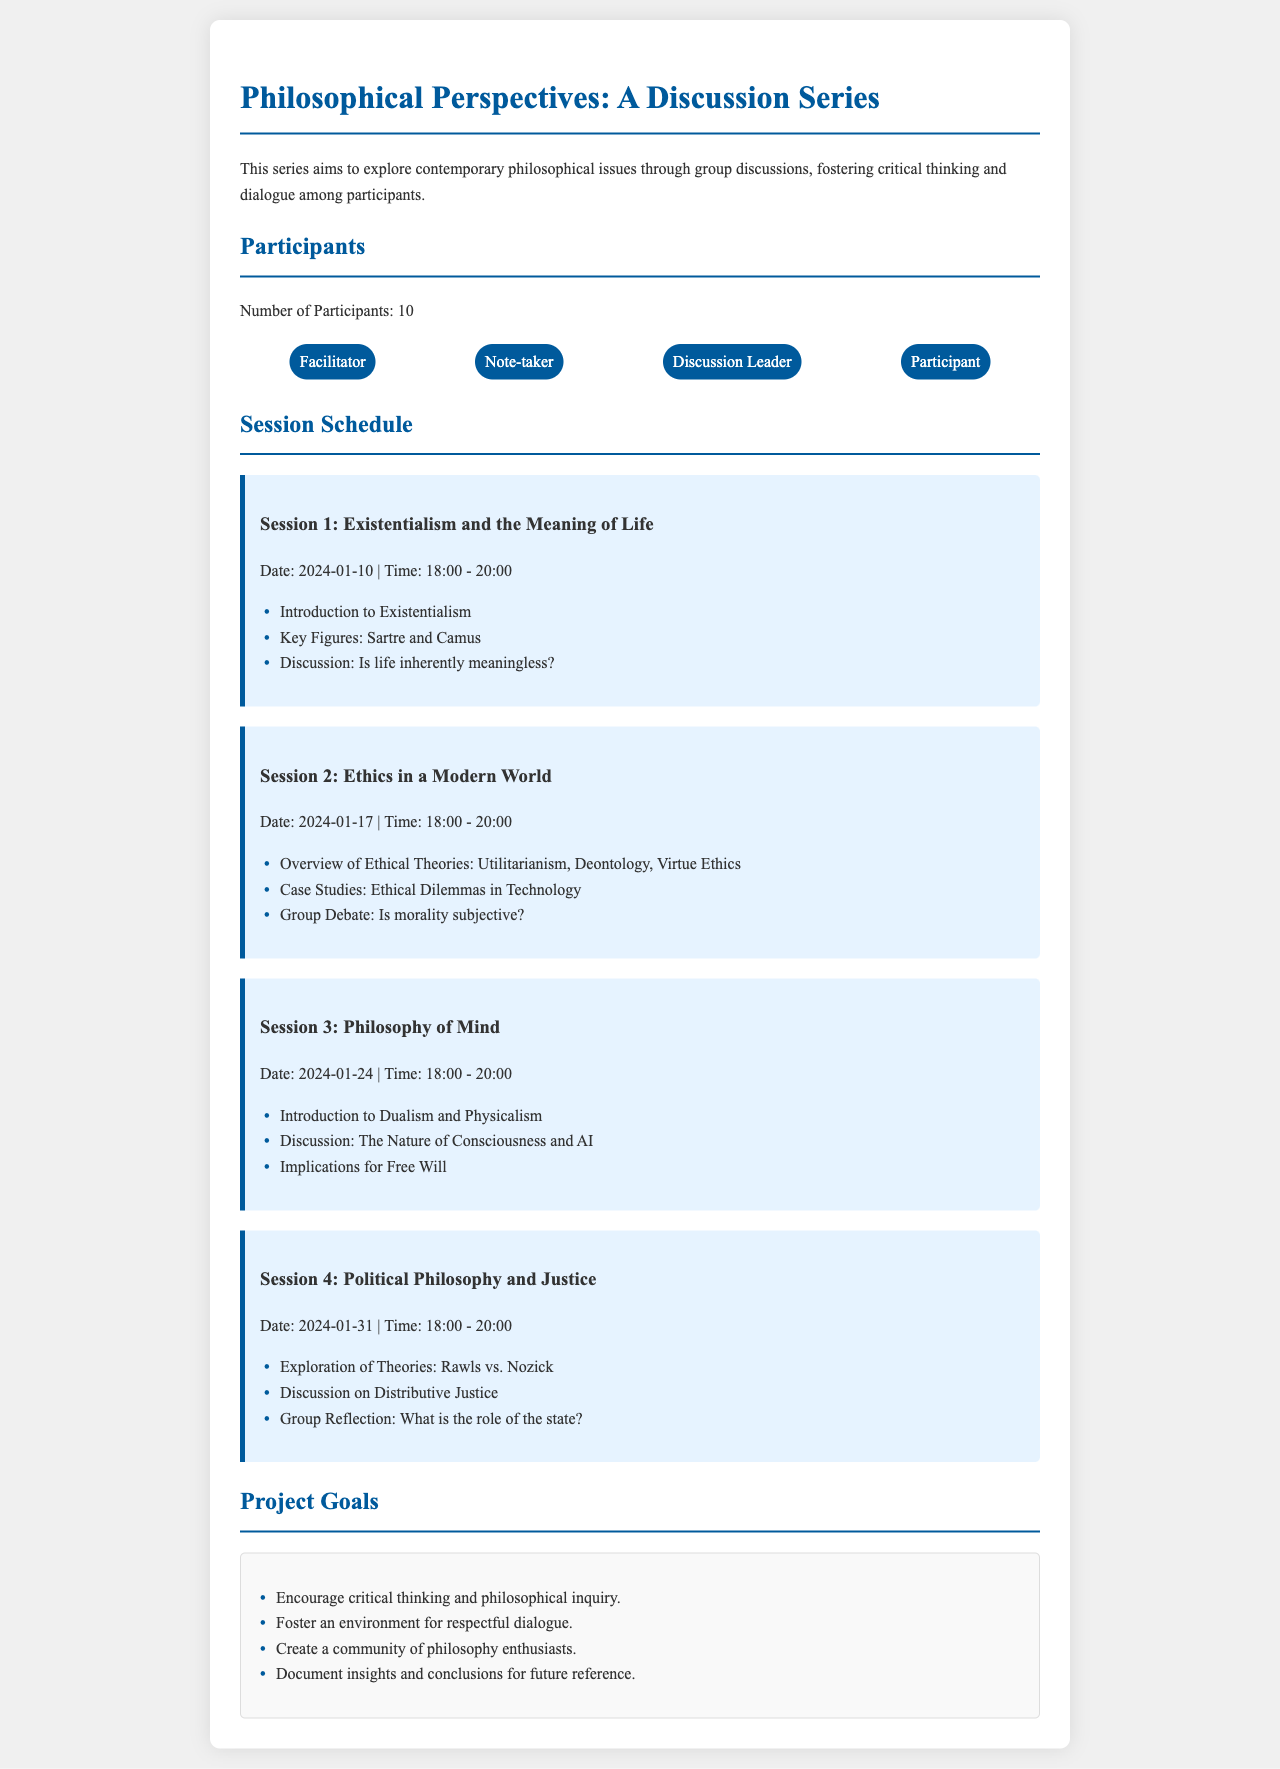what is the title of the discussion series? The title is mentioned at the top of the document.
Answer: Philosophical Perspectives: A Discussion Series how many participants are there? The number of participants is stated in the "Participants" section of the document.
Answer: 10 when is the first session scheduled? The date of the first session is provided in the schedule section.
Answer: 2024-01-10 which philosophers are discussed in Session 1? The key figures for Session 1 are listed under that session's outline.
Answer: Sartre and Camus what ethical theories are introduced in Session 2? The overview of ethical theories is specified in the outline for Session 2.
Answer: Utilitarianism, Deontology, Virtue Ethics what is one of the project goals? A list of project goals is provided in the "Project Goals" section.
Answer: Encourage critical thinking and philosophical inquiry what topic is covered in Session 3? Each session is dedicated to a specific philosophical topic, which is listed.
Answer: Philosophy of Mind what is the time for the sessions? The time for the discussions is uniform across sessions and is specified.
Answer: 18:00 - 20:00 